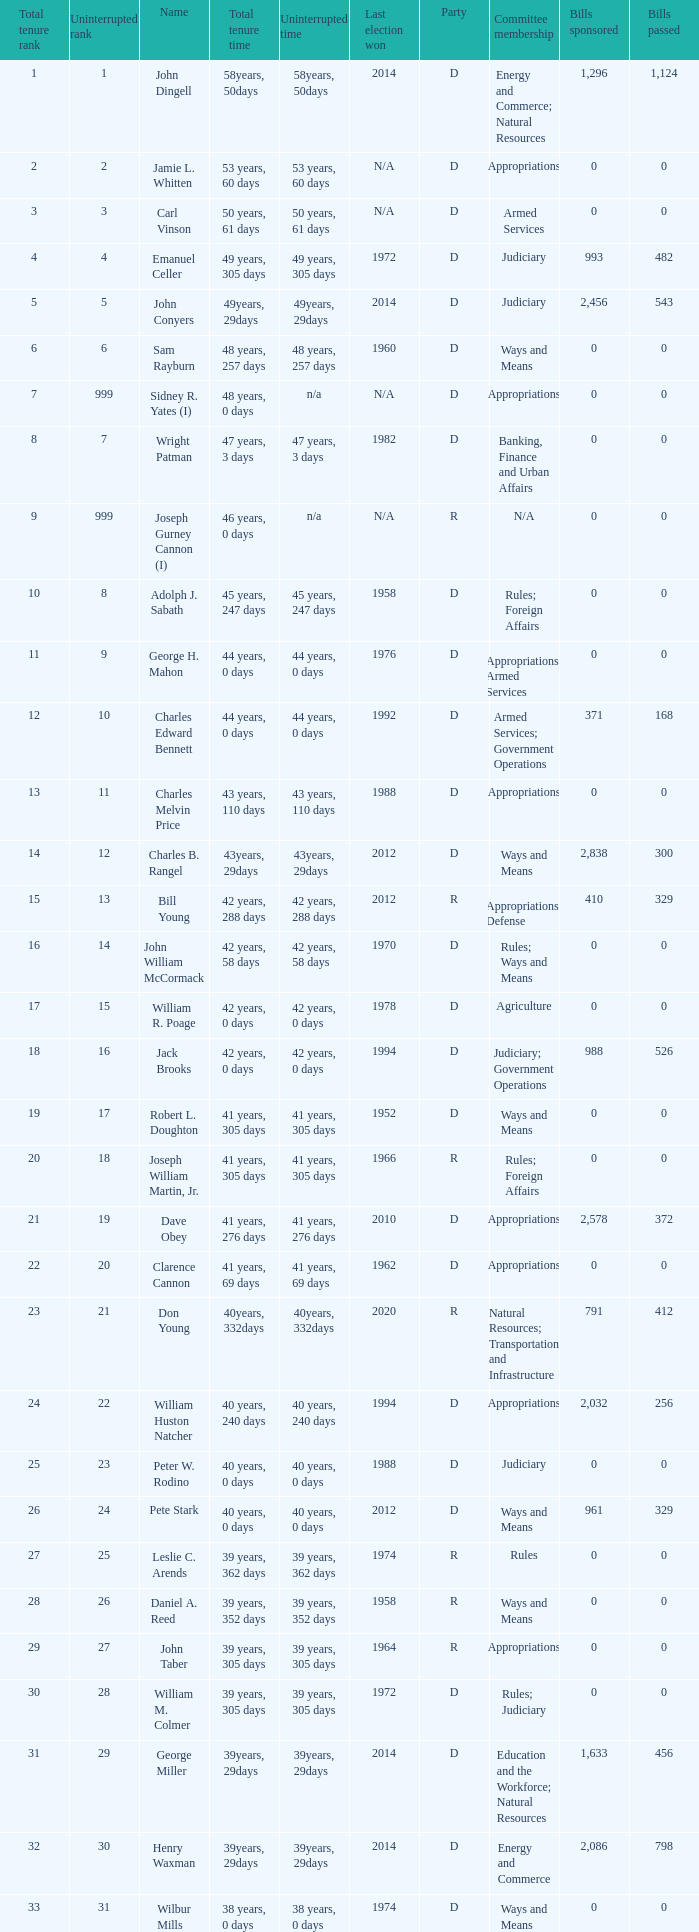Who has a total tenure time and uninterrupted time of 36 years, 0 days, as well as a total tenure rank of 49? James Oberstar. 